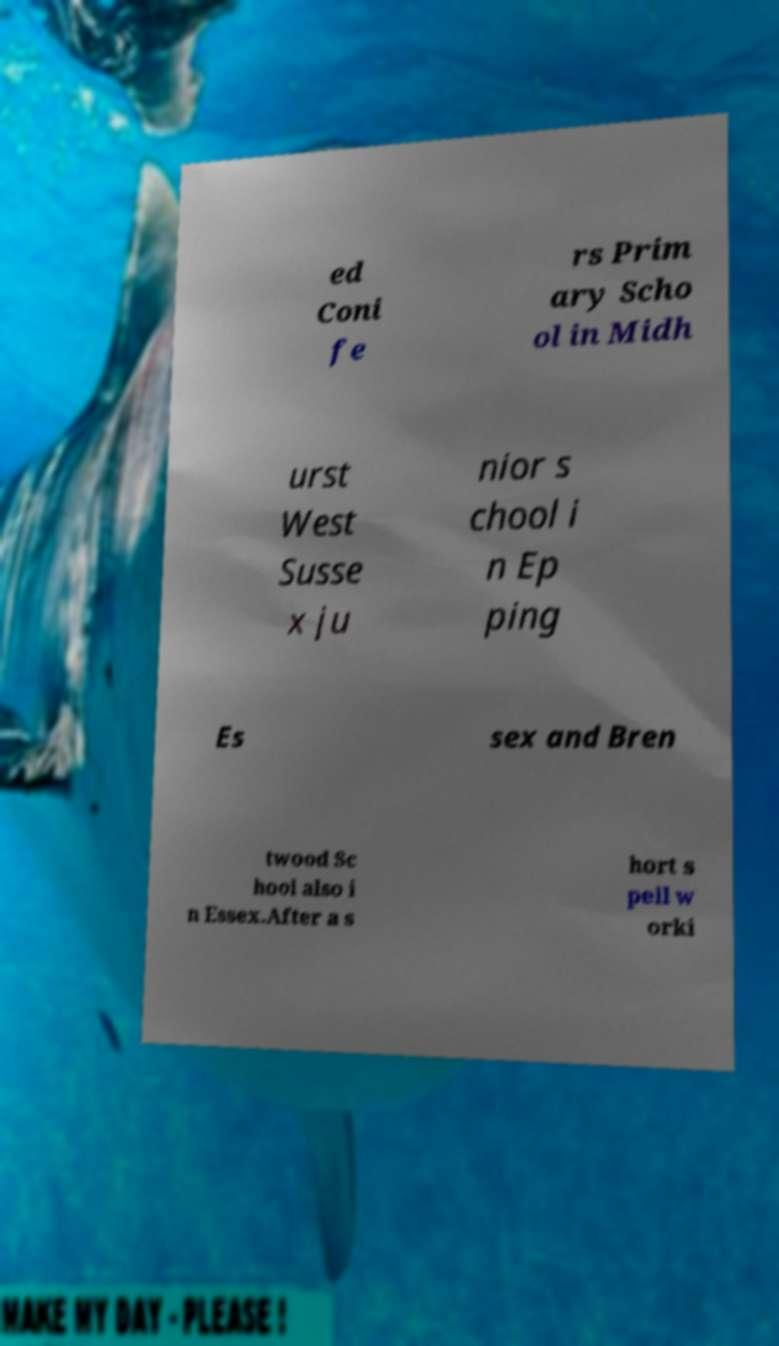Could you extract and type out the text from this image? ed Coni fe rs Prim ary Scho ol in Midh urst West Susse x ju nior s chool i n Ep ping Es sex and Bren twood Sc hool also i n Essex.After a s hort s pell w orki 